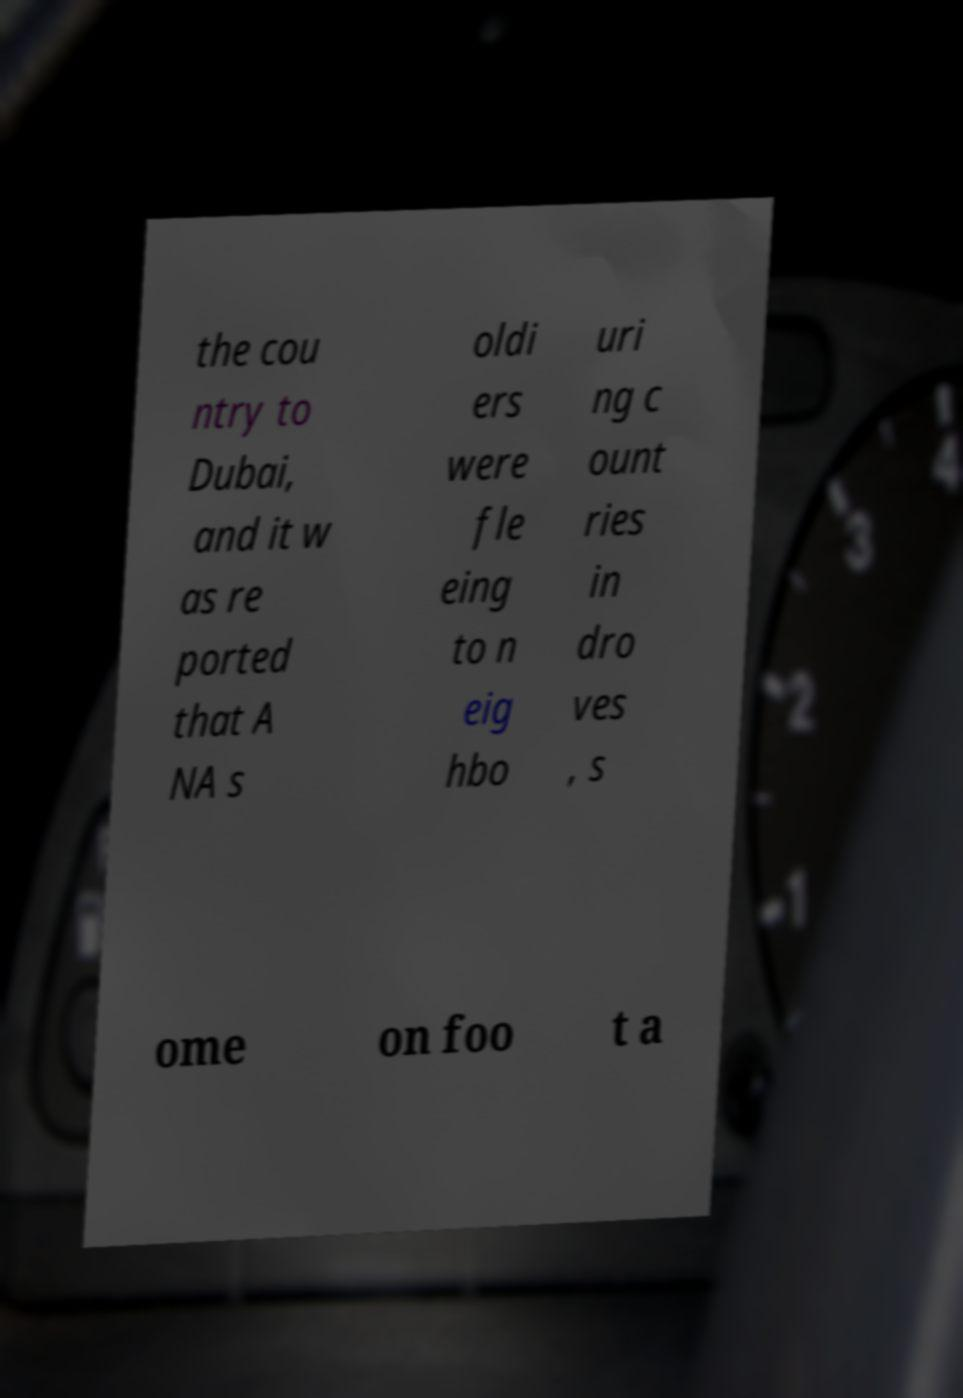Please read and relay the text visible in this image. What does it say? the cou ntry to Dubai, and it w as re ported that A NA s oldi ers were fle eing to n eig hbo uri ng c ount ries in dro ves , s ome on foo t a 